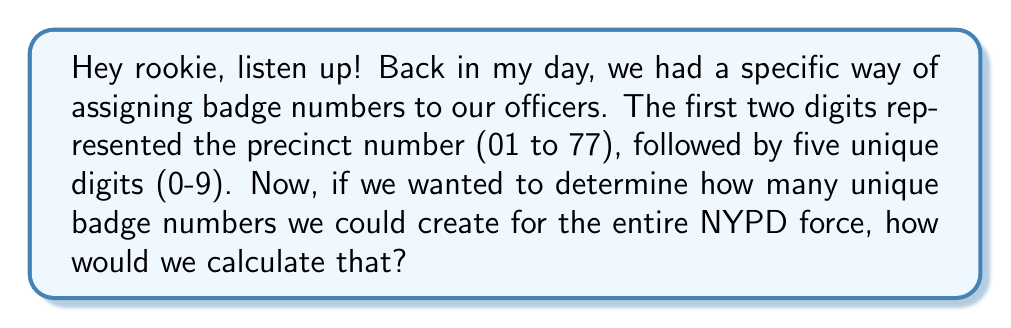Help me with this question. Alright, let's break this down step-by-step:

1) First, we need to consider the precinct numbers. In the NYPD, precincts are numbered from 01 to 77, but not all numbers in this range are used. There are actually 77 precincts in total.

2) For the first two digits of the badge number, we have 77 choices.

3) For the remaining five digits, we can use any digit from 0 to 9 for each position. This means we have 10 choices for each of these five positions.

4) To calculate the total number of possible combinations, we use the multiplication principle. We multiply the number of choices for each position:

   $$ 77 \times 10 \times 10 \times 10 \times 10 \times 10 $$

5) This can be simplified to:

   $$ 77 \times 10^5 $$

6) Let's calculate this:
   $$ 77 \times 100,000 = 7,700,000 $$

Therefore, the total number of unique badge numbers that could be created using this system is 7,700,000.
Answer: $7,700,000$ unique badge numbers 